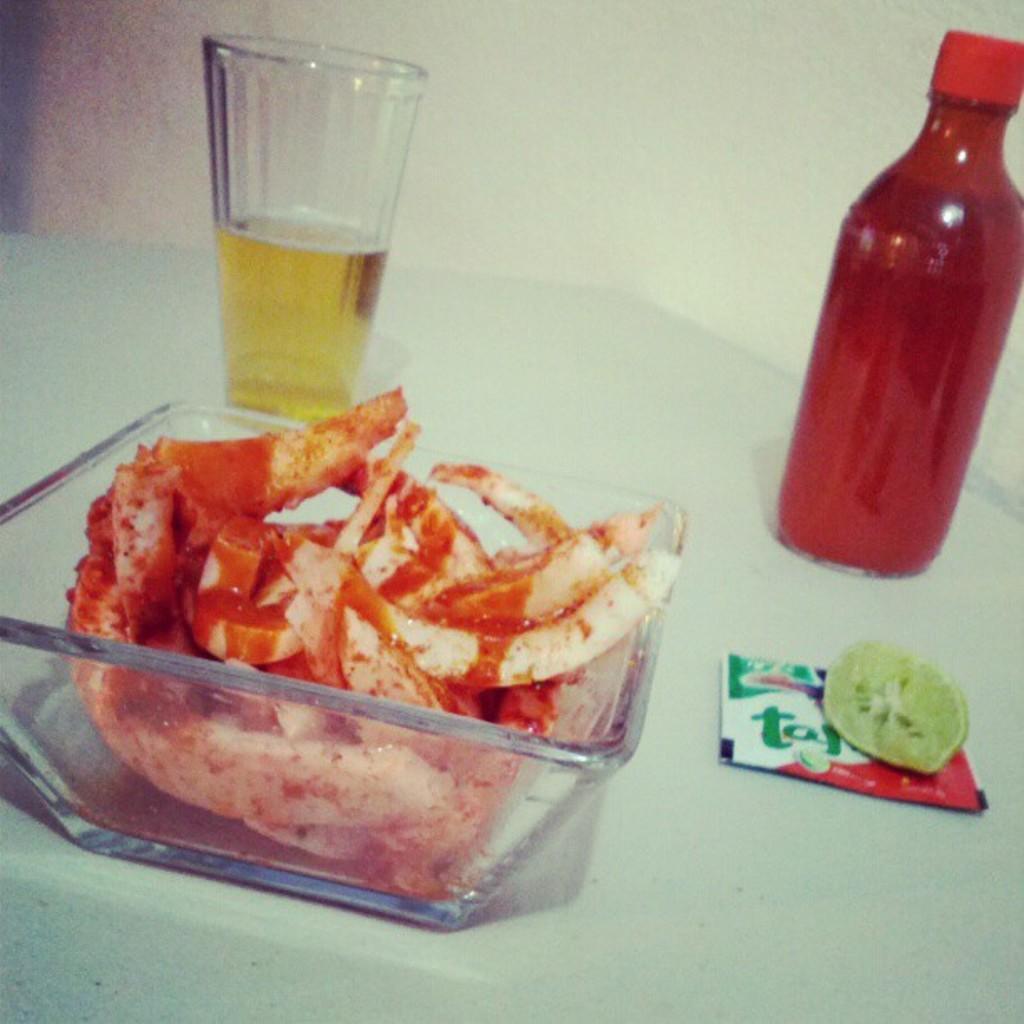Describe this image in one or two sentences. in this picture we see a glass a water bottle and a lemon slice and a food bowl 